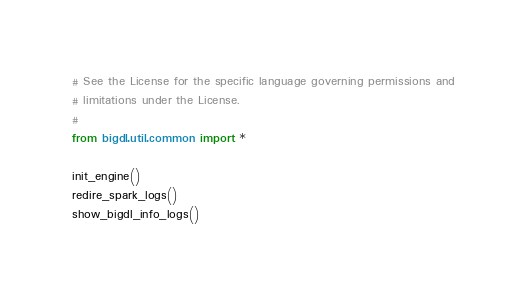<code> <loc_0><loc_0><loc_500><loc_500><_Python_># See the License for the specific language governing permissions and
# limitations under the License.
#
from bigdl.util.common import *

init_engine()
redire_spark_logs()
show_bigdl_info_logs()
</code> 